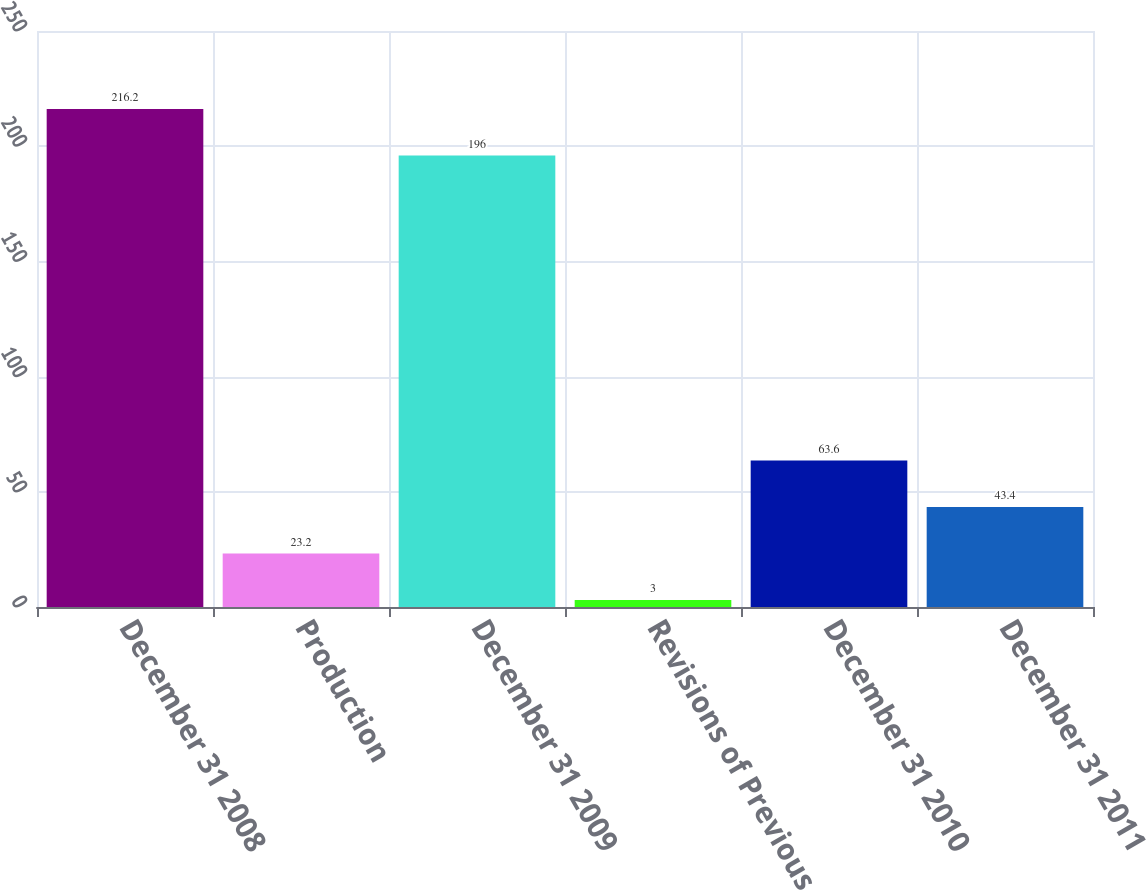Convert chart to OTSL. <chart><loc_0><loc_0><loc_500><loc_500><bar_chart><fcel>December 31 2008<fcel>Production<fcel>December 31 2009<fcel>Revisions of Previous<fcel>December 31 2010<fcel>December 31 2011<nl><fcel>216.2<fcel>23.2<fcel>196<fcel>3<fcel>63.6<fcel>43.4<nl></chart> 